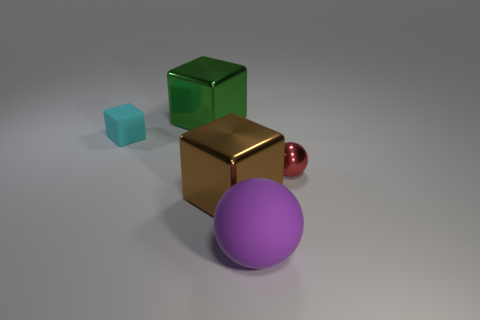Could this image be used educationally, and if so, how? Yes, this image could be used educationally in various ways. For example, it can serve as a tool for teaching basic geometry and colors to children. In a more advanced setting, it might be used to discuss properties of materials, light, and shadow in physics or photography classes, or to explain 3D modeling and rendering techniques in a digital art course. 